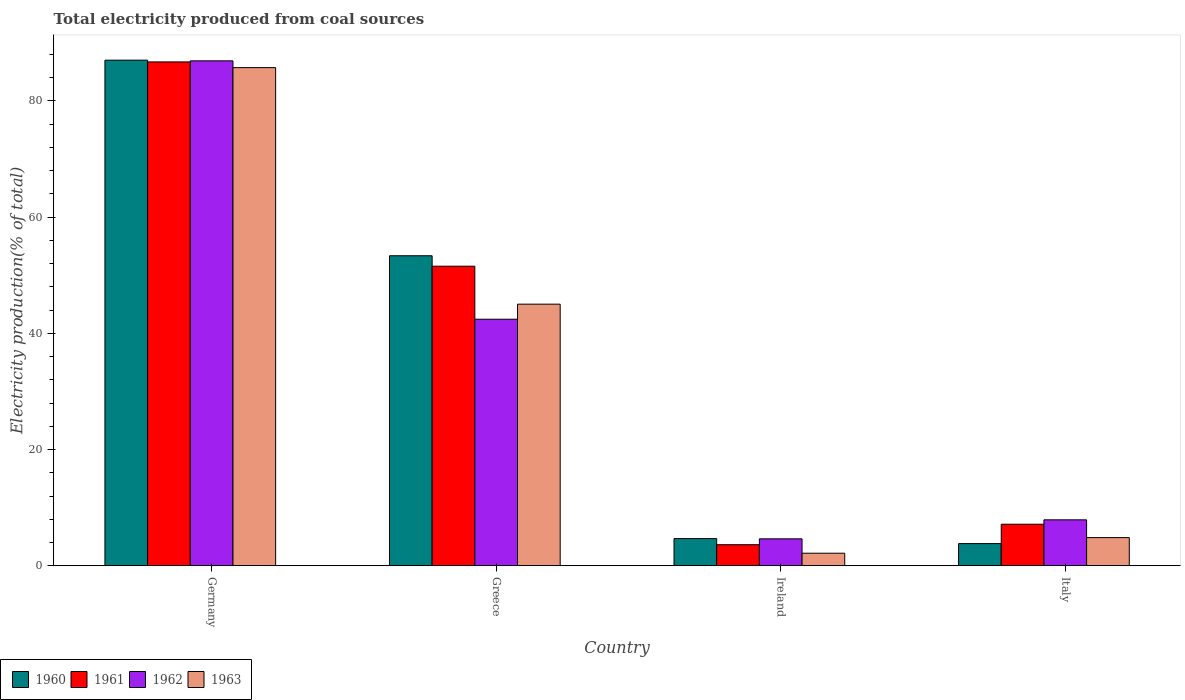How many groups of bars are there?
Provide a short and direct response. 4. Are the number of bars on each tick of the X-axis equal?
Give a very brief answer. Yes. What is the total electricity produced in 1963 in Greece?
Offer a very short reply. 45.03. Across all countries, what is the maximum total electricity produced in 1960?
Provide a short and direct response. 87.03. Across all countries, what is the minimum total electricity produced in 1962?
Your answer should be very brief. 4.64. In which country was the total electricity produced in 1963 minimum?
Give a very brief answer. Ireland. What is the total total electricity produced in 1960 in the graph?
Your answer should be compact. 148.9. What is the difference between the total electricity produced in 1963 in Ireland and that in Italy?
Keep it short and to the point. -2.69. What is the difference between the total electricity produced in 1963 in Germany and the total electricity produced in 1962 in Italy?
Offer a very short reply. 77.83. What is the average total electricity produced in 1962 per country?
Your answer should be very brief. 35.47. What is the difference between the total electricity produced of/in 1961 and total electricity produced of/in 1960 in Ireland?
Ensure brevity in your answer.  -1.06. What is the ratio of the total electricity produced in 1963 in Greece to that in Italy?
Ensure brevity in your answer.  9.28. What is the difference between the highest and the second highest total electricity produced in 1962?
Provide a succinct answer. -44.47. What is the difference between the highest and the lowest total electricity produced in 1962?
Offer a terse response. 82.27. In how many countries, is the total electricity produced in 1963 greater than the average total electricity produced in 1963 taken over all countries?
Keep it short and to the point. 2. Is the sum of the total electricity produced in 1960 in Germany and Italy greater than the maximum total electricity produced in 1961 across all countries?
Your answer should be very brief. Yes. How many bars are there?
Provide a short and direct response. 16. Are all the bars in the graph horizontal?
Your answer should be compact. No. What is the difference between two consecutive major ticks on the Y-axis?
Give a very brief answer. 20. Are the values on the major ticks of Y-axis written in scientific E-notation?
Provide a succinct answer. No. Does the graph contain any zero values?
Offer a terse response. No. Does the graph contain grids?
Your response must be concise. No. What is the title of the graph?
Keep it short and to the point. Total electricity produced from coal sources. What is the label or title of the X-axis?
Your response must be concise. Country. What is the Electricity production(% of total) in 1960 in Germany?
Keep it short and to the point. 87.03. What is the Electricity production(% of total) in 1961 in Germany?
Give a very brief answer. 86.73. What is the Electricity production(% of total) of 1962 in Germany?
Your response must be concise. 86.91. What is the Electricity production(% of total) in 1963 in Germany?
Give a very brief answer. 85.74. What is the Electricity production(% of total) of 1960 in Greece?
Your answer should be very brief. 53.36. What is the Electricity production(% of total) in 1961 in Greece?
Make the answer very short. 51.56. What is the Electricity production(% of total) in 1962 in Greece?
Provide a succinct answer. 42.44. What is the Electricity production(% of total) of 1963 in Greece?
Provide a succinct answer. 45.03. What is the Electricity production(% of total) of 1960 in Ireland?
Provide a succinct answer. 4.69. What is the Electricity production(% of total) in 1961 in Ireland?
Your response must be concise. 3.63. What is the Electricity production(% of total) of 1962 in Ireland?
Give a very brief answer. 4.64. What is the Electricity production(% of total) in 1963 in Ireland?
Your response must be concise. 2.16. What is the Electricity production(% of total) of 1960 in Italy?
Ensure brevity in your answer.  3.82. What is the Electricity production(% of total) in 1961 in Italy?
Provide a short and direct response. 7.15. What is the Electricity production(% of total) of 1962 in Italy?
Your answer should be very brief. 7.91. What is the Electricity production(% of total) in 1963 in Italy?
Provide a short and direct response. 4.85. Across all countries, what is the maximum Electricity production(% of total) in 1960?
Offer a terse response. 87.03. Across all countries, what is the maximum Electricity production(% of total) in 1961?
Provide a succinct answer. 86.73. Across all countries, what is the maximum Electricity production(% of total) in 1962?
Make the answer very short. 86.91. Across all countries, what is the maximum Electricity production(% of total) of 1963?
Ensure brevity in your answer.  85.74. Across all countries, what is the minimum Electricity production(% of total) in 1960?
Provide a succinct answer. 3.82. Across all countries, what is the minimum Electricity production(% of total) in 1961?
Offer a terse response. 3.63. Across all countries, what is the minimum Electricity production(% of total) of 1962?
Offer a very short reply. 4.64. Across all countries, what is the minimum Electricity production(% of total) of 1963?
Ensure brevity in your answer.  2.16. What is the total Electricity production(% of total) in 1960 in the graph?
Offer a terse response. 148.9. What is the total Electricity production(% of total) in 1961 in the graph?
Give a very brief answer. 149.07. What is the total Electricity production(% of total) of 1962 in the graph?
Your answer should be very brief. 141.9. What is the total Electricity production(% of total) of 1963 in the graph?
Offer a terse response. 137.79. What is the difference between the Electricity production(% of total) of 1960 in Germany and that in Greece?
Provide a succinct answer. 33.67. What is the difference between the Electricity production(% of total) in 1961 in Germany and that in Greece?
Offer a very short reply. 35.16. What is the difference between the Electricity production(% of total) of 1962 in Germany and that in Greece?
Give a very brief answer. 44.47. What is the difference between the Electricity production(% of total) in 1963 in Germany and that in Greece?
Make the answer very short. 40.71. What is the difference between the Electricity production(% of total) of 1960 in Germany and that in Ireland?
Provide a succinct answer. 82.34. What is the difference between the Electricity production(% of total) in 1961 in Germany and that in Ireland?
Ensure brevity in your answer.  83.1. What is the difference between the Electricity production(% of total) of 1962 in Germany and that in Ireland?
Your answer should be compact. 82.27. What is the difference between the Electricity production(% of total) in 1963 in Germany and that in Ireland?
Give a very brief answer. 83.58. What is the difference between the Electricity production(% of total) of 1960 in Germany and that in Italy?
Your answer should be very brief. 83.21. What is the difference between the Electricity production(% of total) of 1961 in Germany and that in Italy?
Provide a succinct answer. 79.57. What is the difference between the Electricity production(% of total) in 1962 in Germany and that in Italy?
Make the answer very short. 79. What is the difference between the Electricity production(% of total) in 1963 in Germany and that in Italy?
Provide a short and direct response. 80.89. What is the difference between the Electricity production(% of total) in 1960 in Greece and that in Ireland?
Keep it short and to the point. 48.68. What is the difference between the Electricity production(% of total) of 1961 in Greece and that in Ireland?
Provide a succinct answer. 47.93. What is the difference between the Electricity production(% of total) in 1962 in Greece and that in Ireland?
Ensure brevity in your answer.  37.8. What is the difference between the Electricity production(% of total) in 1963 in Greece and that in Ireland?
Your response must be concise. 42.87. What is the difference between the Electricity production(% of total) in 1960 in Greece and that in Italy?
Ensure brevity in your answer.  49.54. What is the difference between the Electricity production(% of total) of 1961 in Greece and that in Italy?
Your answer should be compact. 44.41. What is the difference between the Electricity production(% of total) of 1962 in Greece and that in Italy?
Provide a succinct answer. 34.53. What is the difference between the Electricity production(% of total) in 1963 in Greece and that in Italy?
Offer a very short reply. 40.18. What is the difference between the Electricity production(% of total) in 1960 in Ireland and that in Italy?
Your response must be concise. 0.87. What is the difference between the Electricity production(% of total) of 1961 in Ireland and that in Italy?
Give a very brief answer. -3.53. What is the difference between the Electricity production(% of total) in 1962 in Ireland and that in Italy?
Your answer should be compact. -3.27. What is the difference between the Electricity production(% of total) in 1963 in Ireland and that in Italy?
Ensure brevity in your answer.  -2.69. What is the difference between the Electricity production(% of total) in 1960 in Germany and the Electricity production(% of total) in 1961 in Greece?
Give a very brief answer. 35.47. What is the difference between the Electricity production(% of total) in 1960 in Germany and the Electricity production(% of total) in 1962 in Greece?
Your response must be concise. 44.59. What is the difference between the Electricity production(% of total) in 1960 in Germany and the Electricity production(% of total) in 1963 in Greece?
Your response must be concise. 42. What is the difference between the Electricity production(% of total) of 1961 in Germany and the Electricity production(% of total) of 1962 in Greece?
Keep it short and to the point. 44.29. What is the difference between the Electricity production(% of total) of 1961 in Germany and the Electricity production(% of total) of 1963 in Greece?
Make the answer very short. 41.69. What is the difference between the Electricity production(% of total) of 1962 in Germany and the Electricity production(% of total) of 1963 in Greece?
Make the answer very short. 41.88. What is the difference between the Electricity production(% of total) of 1960 in Germany and the Electricity production(% of total) of 1961 in Ireland?
Offer a terse response. 83.4. What is the difference between the Electricity production(% of total) of 1960 in Germany and the Electricity production(% of total) of 1962 in Ireland?
Provide a succinct answer. 82.39. What is the difference between the Electricity production(% of total) of 1960 in Germany and the Electricity production(% of total) of 1963 in Ireland?
Provide a succinct answer. 84.86. What is the difference between the Electricity production(% of total) in 1961 in Germany and the Electricity production(% of total) in 1962 in Ireland?
Your response must be concise. 82.08. What is the difference between the Electricity production(% of total) in 1961 in Germany and the Electricity production(% of total) in 1963 in Ireland?
Provide a succinct answer. 84.56. What is the difference between the Electricity production(% of total) in 1962 in Germany and the Electricity production(% of total) in 1963 in Ireland?
Provide a succinct answer. 84.74. What is the difference between the Electricity production(% of total) of 1960 in Germany and the Electricity production(% of total) of 1961 in Italy?
Offer a very short reply. 79.87. What is the difference between the Electricity production(% of total) in 1960 in Germany and the Electricity production(% of total) in 1962 in Italy?
Provide a succinct answer. 79.12. What is the difference between the Electricity production(% of total) in 1960 in Germany and the Electricity production(% of total) in 1963 in Italy?
Offer a terse response. 82.18. What is the difference between the Electricity production(% of total) in 1961 in Germany and the Electricity production(% of total) in 1962 in Italy?
Your answer should be very brief. 78.82. What is the difference between the Electricity production(% of total) of 1961 in Germany and the Electricity production(% of total) of 1963 in Italy?
Offer a terse response. 81.87. What is the difference between the Electricity production(% of total) in 1962 in Germany and the Electricity production(% of total) in 1963 in Italy?
Provide a succinct answer. 82.06. What is the difference between the Electricity production(% of total) in 1960 in Greece and the Electricity production(% of total) in 1961 in Ireland?
Provide a short and direct response. 49.73. What is the difference between the Electricity production(% of total) in 1960 in Greece and the Electricity production(% of total) in 1962 in Ireland?
Provide a short and direct response. 48.72. What is the difference between the Electricity production(% of total) of 1960 in Greece and the Electricity production(% of total) of 1963 in Ireland?
Offer a terse response. 51.2. What is the difference between the Electricity production(% of total) in 1961 in Greece and the Electricity production(% of total) in 1962 in Ireland?
Provide a short and direct response. 46.92. What is the difference between the Electricity production(% of total) of 1961 in Greece and the Electricity production(% of total) of 1963 in Ireland?
Provide a succinct answer. 49.4. What is the difference between the Electricity production(% of total) in 1962 in Greece and the Electricity production(% of total) in 1963 in Ireland?
Your response must be concise. 40.27. What is the difference between the Electricity production(% of total) in 1960 in Greece and the Electricity production(% of total) in 1961 in Italy?
Your answer should be compact. 46.21. What is the difference between the Electricity production(% of total) in 1960 in Greece and the Electricity production(% of total) in 1962 in Italy?
Provide a succinct answer. 45.45. What is the difference between the Electricity production(% of total) in 1960 in Greece and the Electricity production(% of total) in 1963 in Italy?
Your answer should be compact. 48.51. What is the difference between the Electricity production(% of total) in 1961 in Greece and the Electricity production(% of total) in 1962 in Italy?
Your response must be concise. 43.65. What is the difference between the Electricity production(% of total) of 1961 in Greece and the Electricity production(% of total) of 1963 in Italy?
Your response must be concise. 46.71. What is the difference between the Electricity production(% of total) of 1962 in Greece and the Electricity production(% of total) of 1963 in Italy?
Keep it short and to the point. 37.59. What is the difference between the Electricity production(% of total) of 1960 in Ireland and the Electricity production(% of total) of 1961 in Italy?
Offer a very short reply. -2.47. What is the difference between the Electricity production(% of total) in 1960 in Ireland and the Electricity production(% of total) in 1962 in Italy?
Offer a terse response. -3.22. What is the difference between the Electricity production(% of total) in 1960 in Ireland and the Electricity production(% of total) in 1963 in Italy?
Offer a terse response. -0.17. What is the difference between the Electricity production(% of total) of 1961 in Ireland and the Electricity production(% of total) of 1962 in Italy?
Give a very brief answer. -4.28. What is the difference between the Electricity production(% of total) in 1961 in Ireland and the Electricity production(% of total) in 1963 in Italy?
Provide a short and direct response. -1.22. What is the difference between the Electricity production(% of total) of 1962 in Ireland and the Electricity production(% of total) of 1963 in Italy?
Ensure brevity in your answer.  -0.21. What is the average Electricity production(% of total) of 1960 per country?
Provide a short and direct response. 37.22. What is the average Electricity production(% of total) of 1961 per country?
Your response must be concise. 37.27. What is the average Electricity production(% of total) in 1962 per country?
Your response must be concise. 35.47. What is the average Electricity production(% of total) of 1963 per country?
Ensure brevity in your answer.  34.45. What is the difference between the Electricity production(% of total) of 1960 and Electricity production(% of total) of 1961 in Germany?
Your answer should be compact. 0.3. What is the difference between the Electricity production(% of total) of 1960 and Electricity production(% of total) of 1962 in Germany?
Your response must be concise. 0.12. What is the difference between the Electricity production(% of total) of 1960 and Electricity production(% of total) of 1963 in Germany?
Your answer should be compact. 1.29. What is the difference between the Electricity production(% of total) of 1961 and Electricity production(% of total) of 1962 in Germany?
Keep it short and to the point. -0.18. What is the difference between the Electricity production(% of total) in 1961 and Electricity production(% of total) in 1963 in Germany?
Give a very brief answer. 0.98. What is the difference between the Electricity production(% of total) of 1962 and Electricity production(% of total) of 1963 in Germany?
Ensure brevity in your answer.  1.17. What is the difference between the Electricity production(% of total) of 1960 and Electricity production(% of total) of 1961 in Greece?
Provide a succinct answer. 1.8. What is the difference between the Electricity production(% of total) of 1960 and Electricity production(% of total) of 1962 in Greece?
Your answer should be compact. 10.92. What is the difference between the Electricity production(% of total) of 1960 and Electricity production(% of total) of 1963 in Greece?
Provide a short and direct response. 8.33. What is the difference between the Electricity production(% of total) in 1961 and Electricity production(% of total) in 1962 in Greece?
Provide a short and direct response. 9.12. What is the difference between the Electricity production(% of total) of 1961 and Electricity production(% of total) of 1963 in Greece?
Offer a terse response. 6.53. What is the difference between the Electricity production(% of total) in 1962 and Electricity production(% of total) in 1963 in Greece?
Offer a terse response. -2.59. What is the difference between the Electricity production(% of total) of 1960 and Electricity production(% of total) of 1961 in Ireland?
Ensure brevity in your answer.  1.06. What is the difference between the Electricity production(% of total) in 1960 and Electricity production(% of total) in 1962 in Ireland?
Your answer should be very brief. 0.05. What is the difference between the Electricity production(% of total) of 1960 and Electricity production(% of total) of 1963 in Ireland?
Offer a very short reply. 2.52. What is the difference between the Electricity production(% of total) of 1961 and Electricity production(% of total) of 1962 in Ireland?
Your response must be concise. -1.01. What is the difference between the Electricity production(% of total) in 1961 and Electricity production(% of total) in 1963 in Ireland?
Offer a terse response. 1.46. What is the difference between the Electricity production(% of total) in 1962 and Electricity production(% of total) in 1963 in Ireland?
Offer a terse response. 2.48. What is the difference between the Electricity production(% of total) in 1960 and Electricity production(% of total) in 1961 in Italy?
Give a very brief answer. -3.34. What is the difference between the Electricity production(% of total) in 1960 and Electricity production(% of total) in 1962 in Italy?
Provide a succinct answer. -4.09. What is the difference between the Electricity production(% of total) in 1960 and Electricity production(% of total) in 1963 in Italy?
Ensure brevity in your answer.  -1.03. What is the difference between the Electricity production(% of total) in 1961 and Electricity production(% of total) in 1962 in Italy?
Your answer should be compact. -0.75. What is the difference between the Electricity production(% of total) of 1961 and Electricity production(% of total) of 1963 in Italy?
Offer a very short reply. 2.3. What is the difference between the Electricity production(% of total) of 1962 and Electricity production(% of total) of 1963 in Italy?
Your answer should be very brief. 3.06. What is the ratio of the Electricity production(% of total) in 1960 in Germany to that in Greece?
Make the answer very short. 1.63. What is the ratio of the Electricity production(% of total) of 1961 in Germany to that in Greece?
Keep it short and to the point. 1.68. What is the ratio of the Electricity production(% of total) in 1962 in Germany to that in Greece?
Your answer should be compact. 2.05. What is the ratio of the Electricity production(% of total) of 1963 in Germany to that in Greece?
Your response must be concise. 1.9. What is the ratio of the Electricity production(% of total) of 1960 in Germany to that in Ireland?
Give a very brief answer. 18.57. What is the ratio of the Electricity production(% of total) in 1961 in Germany to that in Ireland?
Provide a succinct answer. 23.9. What is the ratio of the Electricity production(% of total) of 1962 in Germany to that in Ireland?
Provide a short and direct response. 18.73. What is the ratio of the Electricity production(% of total) of 1963 in Germany to that in Ireland?
Keep it short and to the point. 39.6. What is the ratio of the Electricity production(% of total) in 1960 in Germany to that in Italy?
Offer a very short reply. 22.79. What is the ratio of the Electricity production(% of total) in 1961 in Germany to that in Italy?
Provide a succinct answer. 12.12. What is the ratio of the Electricity production(% of total) of 1962 in Germany to that in Italy?
Offer a terse response. 10.99. What is the ratio of the Electricity production(% of total) of 1963 in Germany to that in Italy?
Give a very brief answer. 17.67. What is the ratio of the Electricity production(% of total) in 1960 in Greece to that in Ireland?
Your response must be concise. 11.39. What is the ratio of the Electricity production(% of total) in 1961 in Greece to that in Ireland?
Keep it short and to the point. 14.21. What is the ratio of the Electricity production(% of total) in 1962 in Greece to that in Ireland?
Ensure brevity in your answer.  9.14. What is the ratio of the Electricity production(% of total) of 1963 in Greece to that in Ireland?
Provide a succinct answer. 20.8. What is the ratio of the Electricity production(% of total) in 1960 in Greece to that in Italy?
Offer a terse response. 13.97. What is the ratio of the Electricity production(% of total) in 1961 in Greece to that in Italy?
Provide a succinct answer. 7.21. What is the ratio of the Electricity production(% of total) in 1962 in Greece to that in Italy?
Offer a very short reply. 5.37. What is the ratio of the Electricity production(% of total) in 1963 in Greece to that in Italy?
Your answer should be very brief. 9.28. What is the ratio of the Electricity production(% of total) in 1960 in Ireland to that in Italy?
Provide a short and direct response. 1.23. What is the ratio of the Electricity production(% of total) in 1961 in Ireland to that in Italy?
Give a very brief answer. 0.51. What is the ratio of the Electricity production(% of total) in 1962 in Ireland to that in Italy?
Make the answer very short. 0.59. What is the ratio of the Electricity production(% of total) of 1963 in Ireland to that in Italy?
Give a very brief answer. 0.45. What is the difference between the highest and the second highest Electricity production(% of total) of 1960?
Offer a terse response. 33.67. What is the difference between the highest and the second highest Electricity production(% of total) of 1961?
Provide a succinct answer. 35.16. What is the difference between the highest and the second highest Electricity production(% of total) in 1962?
Your answer should be compact. 44.47. What is the difference between the highest and the second highest Electricity production(% of total) of 1963?
Keep it short and to the point. 40.71. What is the difference between the highest and the lowest Electricity production(% of total) of 1960?
Provide a succinct answer. 83.21. What is the difference between the highest and the lowest Electricity production(% of total) in 1961?
Give a very brief answer. 83.1. What is the difference between the highest and the lowest Electricity production(% of total) of 1962?
Make the answer very short. 82.27. What is the difference between the highest and the lowest Electricity production(% of total) of 1963?
Your answer should be very brief. 83.58. 